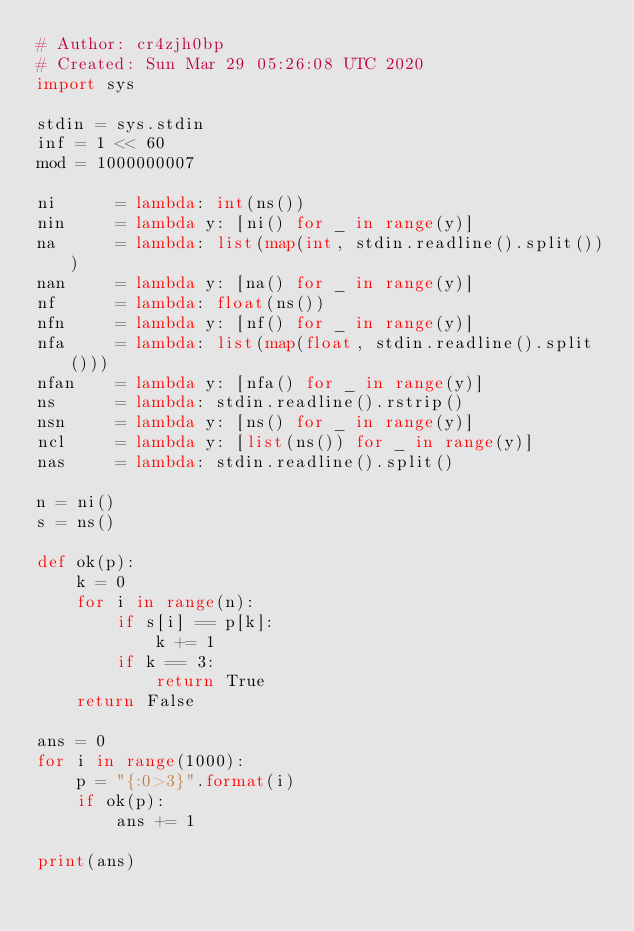Convert code to text. <code><loc_0><loc_0><loc_500><loc_500><_Python_># Author: cr4zjh0bp
# Created: Sun Mar 29 05:26:08 UTC 2020
import sys
 
stdin = sys.stdin
inf = 1 << 60
mod = 1000000007
 
ni      = lambda: int(ns())
nin     = lambda y: [ni() for _ in range(y)]
na      = lambda: list(map(int, stdin.readline().split()))
nan     = lambda y: [na() for _ in range(y)]
nf      = lambda: float(ns())
nfn     = lambda y: [nf() for _ in range(y)]
nfa     = lambda: list(map(float, stdin.readline().split()))
nfan    = lambda y: [nfa() for _ in range(y)]
ns      = lambda: stdin.readline().rstrip()
nsn     = lambda y: [ns() for _ in range(y)]
ncl     = lambda y: [list(ns()) for _ in range(y)]
nas     = lambda: stdin.readline().split()

n = ni()
s = ns()

def ok(p):
    k = 0
    for i in range(n):
        if s[i] == p[k]:
            k += 1
        if k == 3:
            return True
    return False

ans = 0
for i in range(1000):
    p = "{:0>3}".format(i)
    if ok(p):
        ans += 1

print(ans)</code> 